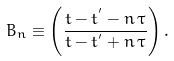Convert formula to latex. <formula><loc_0><loc_0><loc_500><loc_500>B _ { n } \equiv \left ( \frac { t - t ^ { ^ { \prime } } - n \, \tau } { t - t ^ { ^ { \prime } } + n \, \tau } \right ) .</formula> 